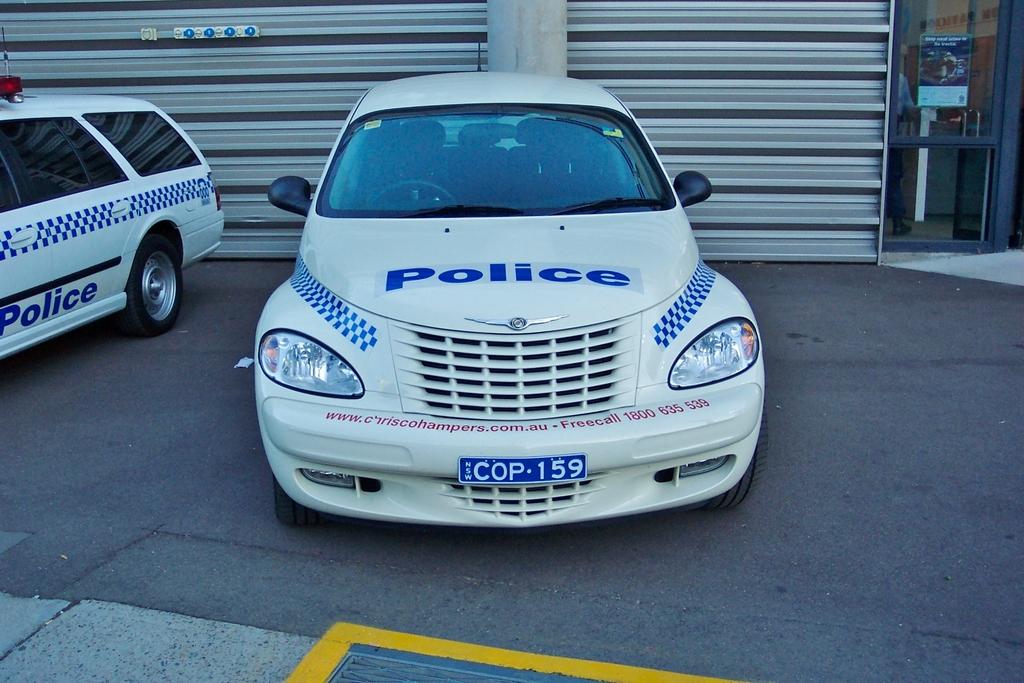What type of car is this?
Ensure brevity in your answer.  Police. What is the license plate number of the car?
Offer a very short reply. Cop 159. 